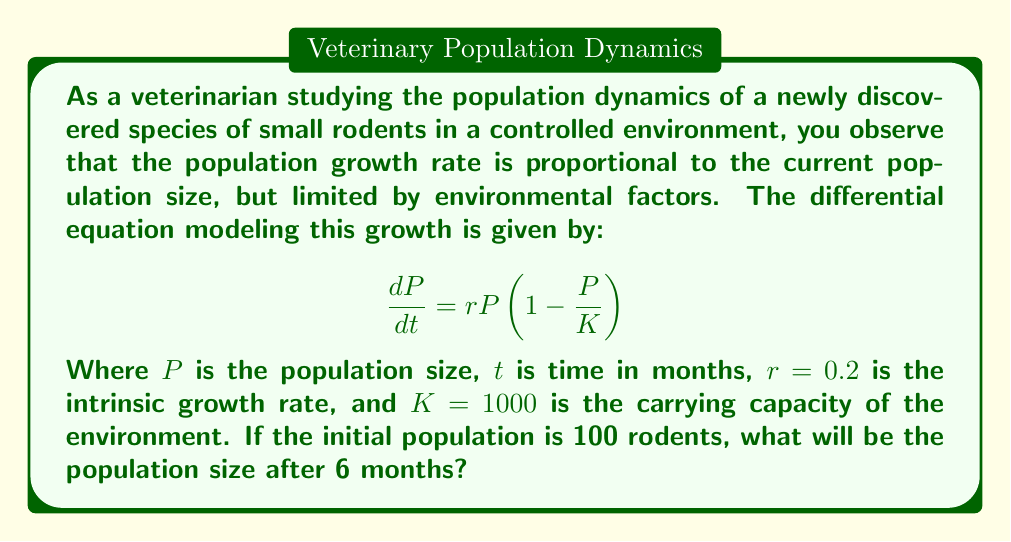Solve this math problem. To solve this problem, we need to use the logistic growth model, which is described by the given differential equation. Let's approach this step-by-step:

1) The solution to the logistic growth equation is:

   $$P(t) = \frac{K}{1 + (\frac{K}{P_0} - 1)e^{-rt}}$$

   Where $P_0$ is the initial population size.

2) We're given the following values:
   - $K = 1000$ (carrying capacity)
   - $r = 0.2$ (intrinsic growth rate)
   - $P_0 = 100$ (initial population)
   - $t = 6$ (time in months)

3) Let's substitute these values into the equation:

   $$P(6) = \frac{1000}{1 + (\frac{1000}{100} - 1)e^{-0.2 \cdot 6}}$$

4) Simplify the fraction inside the parentheses:

   $$P(6) = \frac{1000}{1 + (10 - 1)e^{-1.2}}$$

5) Evaluate $e^{-1.2}$:

   $$P(6) = \frac{1000}{1 + 9 \cdot 0.301194...}$$

6) Multiply inside the parentheses:

   $$P(6) = \frac{1000}{1 + 2.710746...}$$

7) Add in the denominator:

   $$P(6) = \frac{1000}{3.710746...}$$

8) Divide:

   $$P(6) = 269.487...$$

9) Round to the nearest whole number, as we're dealing with a population of rodents:

   $$P(6) \approx 269$$
Answer: 269 rodents 